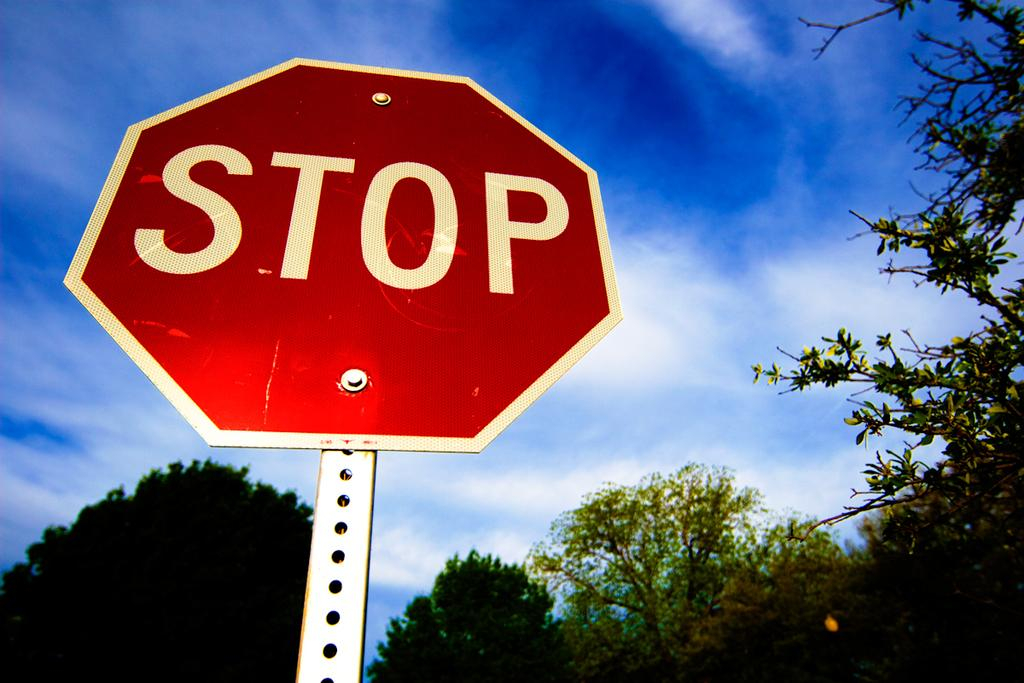<image>
Provide a brief description of the given image. A large STOP sign in the foreground and a blue sky in the background. 